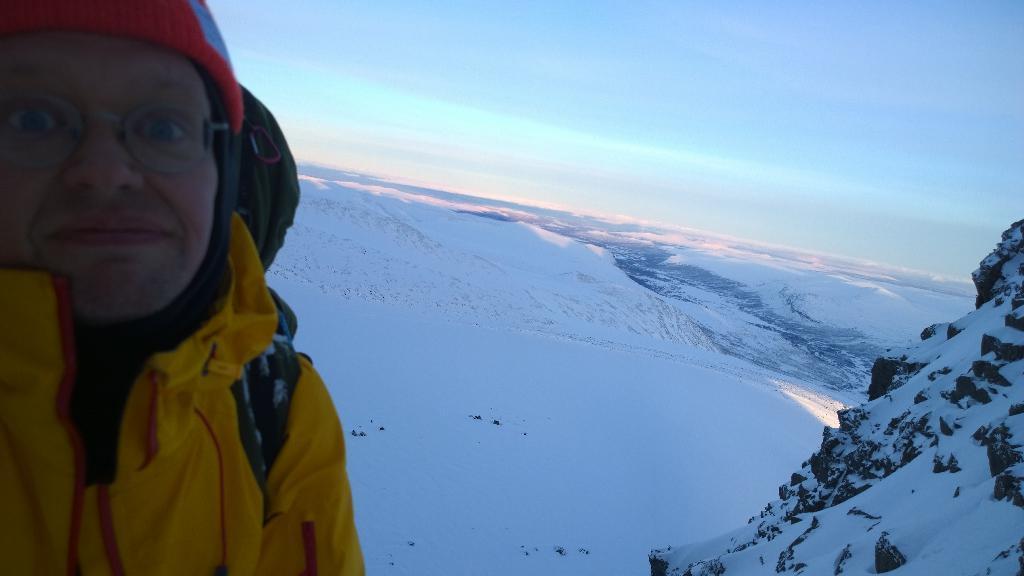Could you give a brief overview of what you see in this image? In this image, I can see a person and there are snowy mountains. In the background, I can see the sky. 